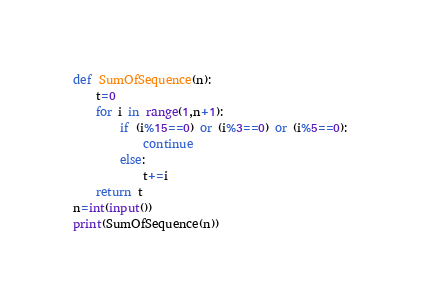Convert code to text. <code><loc_0><loc_0><loc_500><loc_500><_Python_>def SumOfSequence(n):
    t=0
    for i in range(1,n+1):
        if (i%15==0) or (i%3==0) or (i%5==0):
            continue
        else:
            t+=i
    return t
n=int(input())
print(SumOfSequence(n))
</code> 